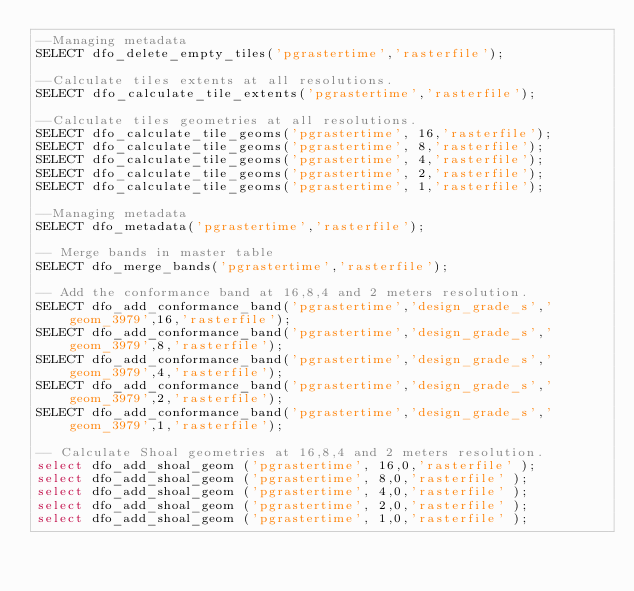Convert code to text. <code><loc_0><loc_0><loc_500><loc_500><_SQL_>--Managing metadata
SELECT dfo_delete_empty_tiles('pgrastertime','rasterfile');

--Calculate tiles extents at all resolutions.
SELECT dfo_calculate_tile_extents('pgrastertime','rasterfile');

--Calculate tiles geometries at all resolutions.
SELECT dfo_calculate_tile_geoms('pgrastertime', 16,'rasterfile');
SELECT dfo_calculate_tile_geoms('pgrastertime', 8,'rasterfile');
SELECT dfo_calculate_tile_geoms('pgrastertime', 4,'rasterfile');
SELECT dfo_calculate_tile_geoms('pgrastertime', 2,'rasterfile');
SELECT dfo_calculate_tile_geoms('pgrastertime', 1,'rasterfile');

--Managing metadata
SELECT dfo_metadata('pgrastertime','rasterfile');

-- Merge bands in master table
SELECT dfo_merge_bands('pgrastertime','rasterfile');

-- Add the conformance band at 16,8,4 and 2 meters resolution.
SELECT dfo_add_conformance_band('pgrastertime','design_grade_s','geom_3979',16,'rasterfile');
SELECT dfo_add_conformance_band('pgrastertime','design_grade_s','geom_3979',8,'rasterfile');
SELECT dfo_add_conformance_band('pgrastertime','design_grade_s','geom_3979',4,'rasterfile');
SELECT dfo_add_conformance_band('pgrastertime','design_grade_s','geom_3979',2,'rasterfile');
SELECT dfo_add_conformance_band('pgrastertime','design_grade_s','geom_3979',1,'rasterfile');

-- Calculate Shoal geometries at 16,8,4 and 2 meters resolution.
select dfo_add_shoal_geom ('pgrastertime', 16,0,'rasterfile' );
select dfo_add_shoal_geom ('pgrastertime', 8,0,'rasterfile' );
select dfo_add_shoal_geom ('pgrastertime', 4,0,'rasterfile' );
select dfo_add_shoal_geom ('pgrastertime', 2,0,'rasterfile' );
select dfo_add_shoal_geom ('pgrastertime', 1,0,'rasterfile' );

</code> 